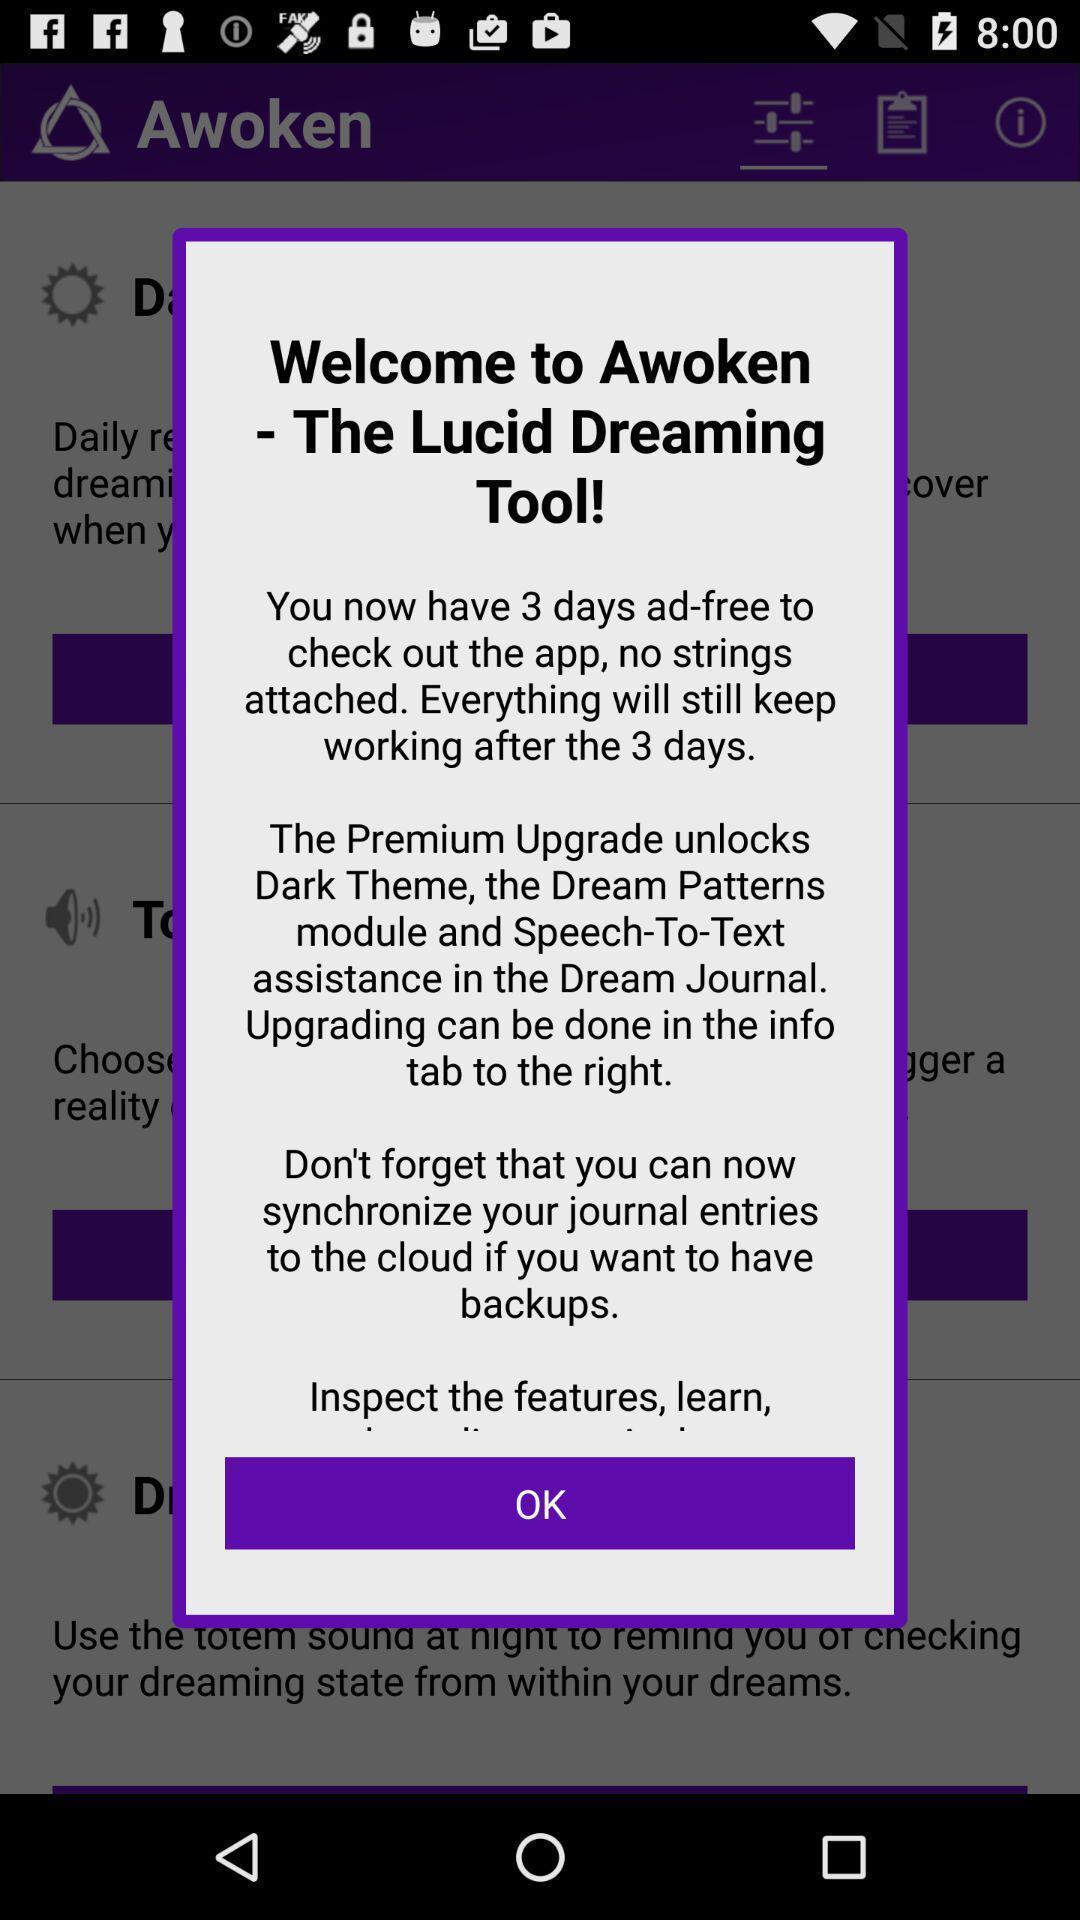Please provide a description for this image. Welcome page. 